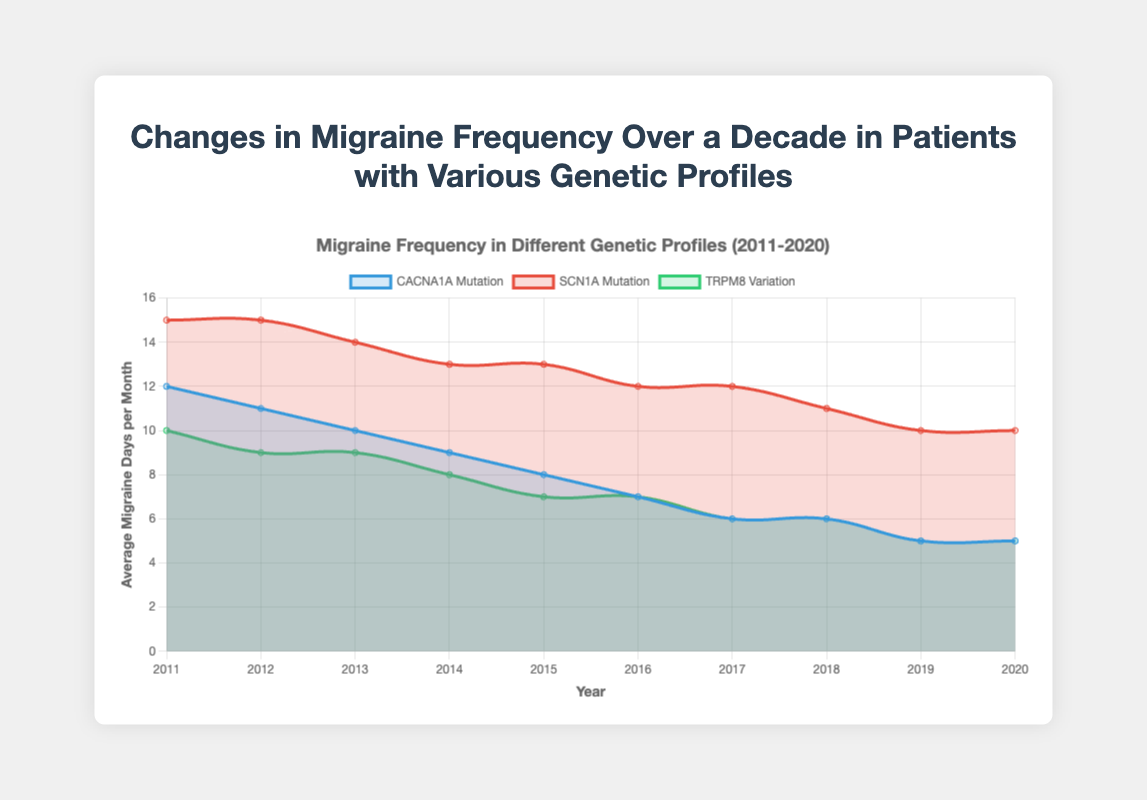What's the trend in average migraine days per month for the CACNA1A Mutation group over the decade? The line plot shows a downward trend for the CACNA1A Mutation group from 12 days in 2011 to 5 days in 2020.
Answer: Downward trend Which patient group had the highest average migraine days per month in 2011? By looking at the plot, we see that the SCN1A Mutation group had the highest average at 15 days in 2011.
Answer: SCN1A Mutation How did migraine frequency change for the TRPM8 Variation group between 2011 and 2020? The plot shows a decrease in average migraine days per month for TRPM8 Variation from 10 days in 2011 to 5 days in 2020.
Answer: Decreased In 2019, which patient group had the lowest average migraine days per month? The plot indicates that both the CACNA1A Mutation and TRPM8 Variation groups had the lowest average at 5 days.
Answer: CACNA1A Mutation and TRPM8 Variation Compare the migraine frequency trends between SCN1A Mutation and TRPM8 Variation groups. The SCN1A Mutation group shows a gradual decline from 15 days to 10 days, while the TRPM8 Variation group shows a sharper decline from 10 days to 5 days over the decade.
Answer: SCN1A Mutation: gradual decline, TRPM8 Variation: sharper decline What is the combined change in average migraine days for the CACNA1A Mutation group between 2011 and 2020? The change can be computed as the difference between the initial value in 2011 (12 days) and the final value in 2020 (5 days), giving a change of 12 - 5 = 7 days.
Answer: 7 days decrease Which patient group showed the most consistent average migraine frequency over the years? The SCN1A Mutation group showcased the most consistency, with smaller fluctuations compared to the other groups.
Answer: SCN1A Mutation How did the migraine frequency for the SCN1A Mutation group change from 2012 to 2018? The SCN1A Mutation group stayed at 15 days from 2012 to 2013, then gradually decreased to 11 days by 2018.
Answer: Decreased from 15 to 11 days Which group had the most significant drop in migraine frequency between 2011 and 2020? The CACNA1A Mutation group had the most significant drop, decreasing from 12 to 5 days per month.
Answer: CACNA1A Mutation What's the difference between the highest and lowest average migraine days per month in 2013? The highest is 14 days for SCN1A Mutation and the lowest is 9 days for TRPM8 Variation, so the difference is 14 - 9 = 5 days.
Answer: 5 days 